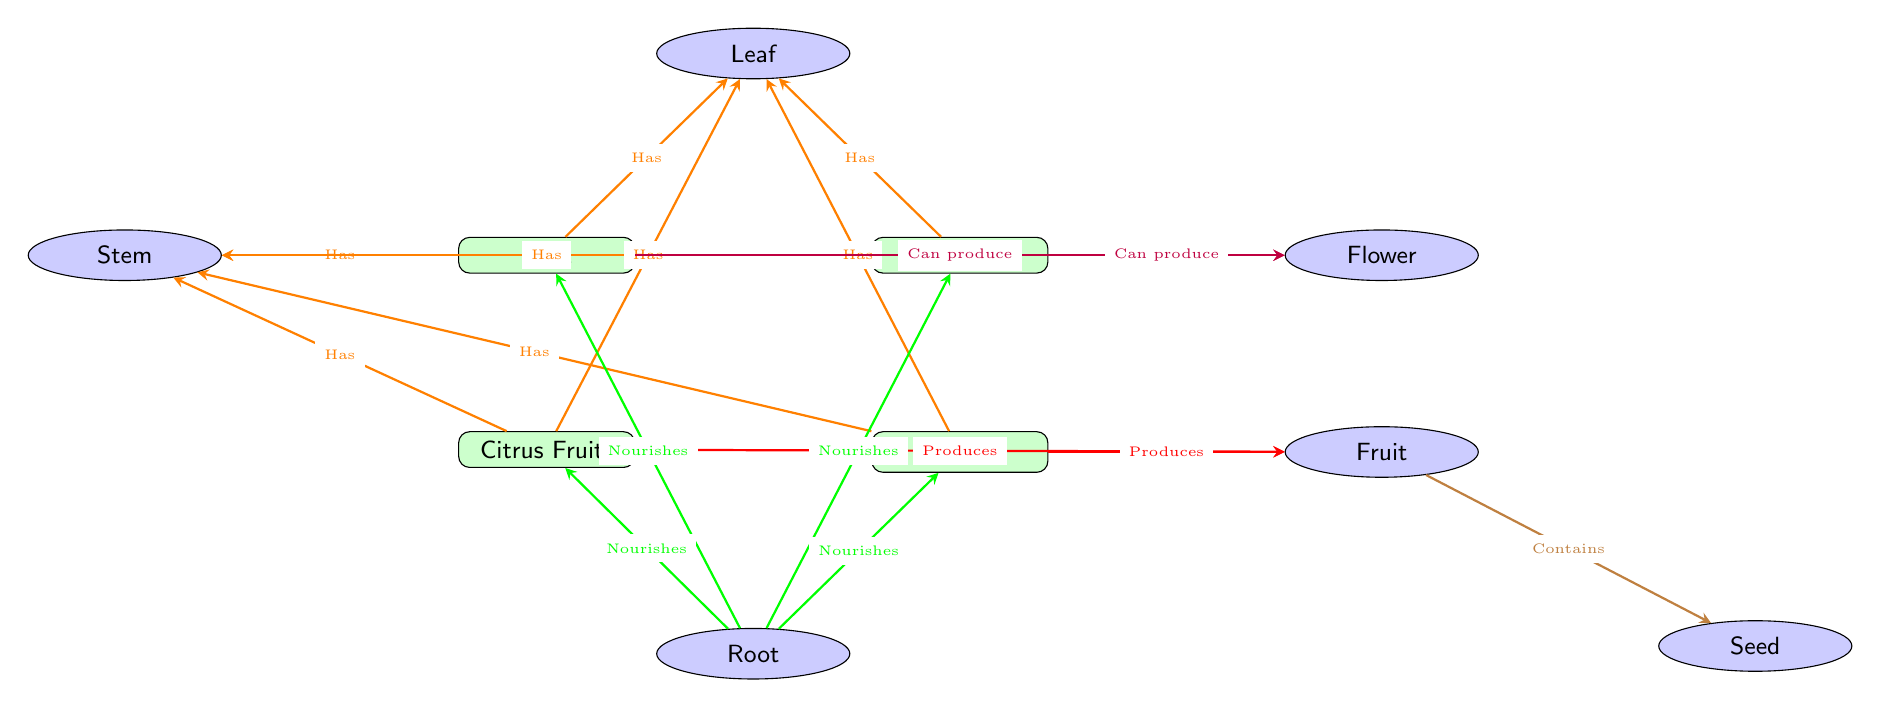What are the four garnishes listed in the diagram? The diagram shows four primary garnishes: Mint, Basil, Citrus Fruits, and Cherry. These are represented as the main nodes in the diagram.
Answer: Mint, Basil, Citrus Fruits, Cherry Which plant part is connected to the mint? The mint is connected to three parts in the diagram: Leaf, Stem, and Flower, as indicated by the arrows pointing towards these nodes.
Answer: Leaf, Stem, Flower How many plant parts are shown in the diagram? There are a total of six distinct plant parts depicted in the diagram: Leaf, Stem, Root, Flower, Fruit, and Seed. This can be visually counted from the part nodes.
Answer: 6 What does the stem provide for the garnishes? The stem functions to support the leaves and conducts water, as described in the diagram under the stem node.
Answer: Supports leaves and conducts water Which fruit is described as having a single hard seed? The description for Cherry in the diagram states it is a small, fleshy fruit with a single hard seed. This is reflected in the node's annotations.
Answer: Cherry What color arrows indicate which garnishes are nourished by the root? The green arrows indicate the relationship where the root nourishes all four garnishes: Mint, Basil, Citrus Fruits, and Cherry. This relationship highlights the importance of roots in plant sustenance.
Answer: Green Which two garnishes can produce flowers? The diagram indicates that both Mint and Basil can produce flowers, as shown by the purple arrows leading from these garnishes to the Flower part.
Answer: Mint, Basil What is the relationship between fruit and seed as shown in the diagram? The brown arrow in the diagram signifies that the fruit contains the seed, visually linking these two parts together under the Fruit node.
Answer: Contains How is the leaf identified in relation to other parts? The leaf is the primary photosynthetic organ, and it is directly connected to all garnishes, indicating its critical role in plant biology as shown by the orange arrows.
Answer: Primary photosynthetic organ 